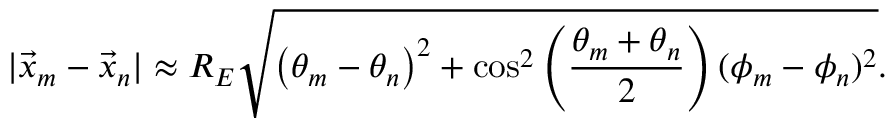<formula> <loc_0><loc_0><loc_500><loc_500>| \vec { x } _ { m } - \vec { x } _ { n } | \approx R _ { E } \sqrt { \left ( \theta _ { m } - \theta _ { n } \right ) ^ { 2 } + \cos ^ { 2 } \left ( \frac { \theta _ { m } + \theta _ { n } } { 2 } \right ) ( \phi _ { m } - \phi _ { n } ) ^ { 2 } } .</formula> 